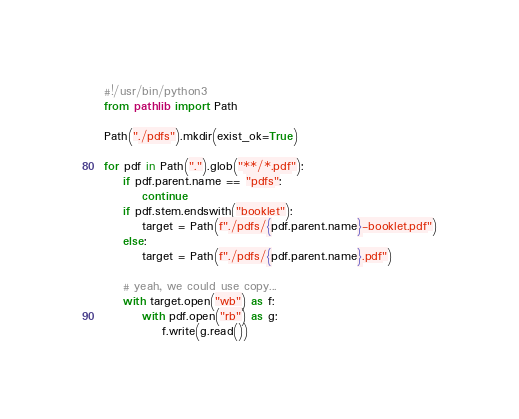<code> <loc_0><loc_0><loc_500><loc_500><_Python_>#!/usr/bin/python3
from pathlib import Path

Path("./pdfs").mkdir(exist_ok=True)

for pdf in Path(".").glob("**/*.pdf"):
    if pdf.parent.name == "pdfs":
        continue
    if pdf.stem.endswith("booklet"):
        target = Path(f"./pdfs/{pdf.parent.name}-booklet.pdf")
    else:
        target = Path(f"./pdfs/{pdf.parent.name}.pdf")

    # yeah, we could use copy...
    with target.open("wb") as f:
        with pdf.open("rb") as g:
            f.write(g.read())
</code> 